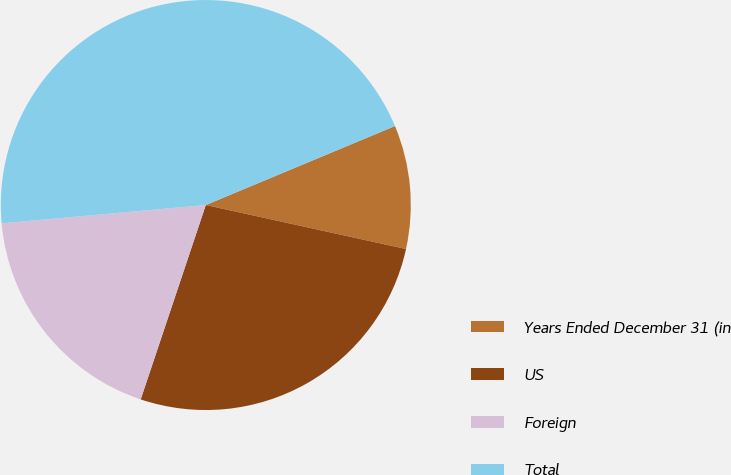Convert chart. <chart><loc_0><loc_0><loc_500><loc_500><pie_chart><fcel>Years Ended December 31 (in<fcel>US<fcel>Foreign<fcel>Total<nl><fcel>9.74%<fcel>26.7%<fcel>18.43%<fcel>45.13%<nl></chart> 